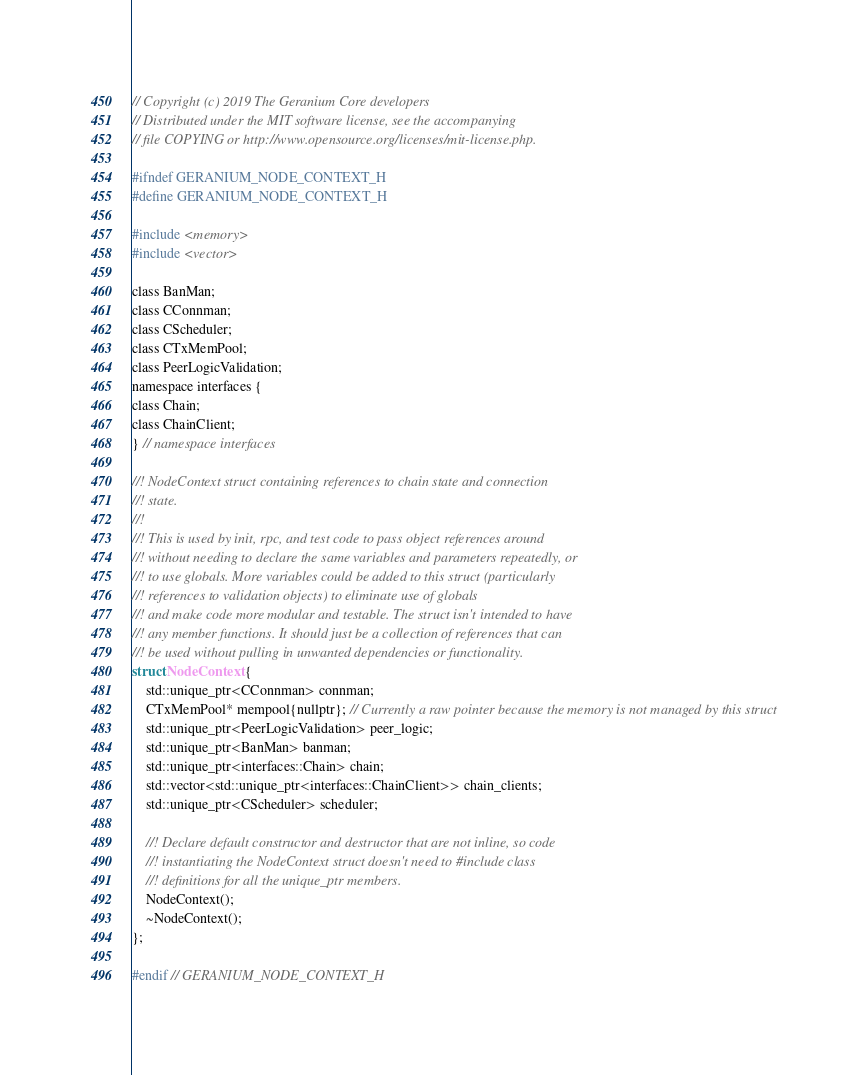<code> <loc_0><loc_0><loc_500><loc_500><_C_>// Copyright (c) 2019 The Geranium Core developers
// Distributed under the MIT software license, see the accompanying
// file COPYING or http://www.opensource.org/licenses/mit-license.php.

#ifndef GERANIUM_NODE_CONTEXT_H
#define GERANIUM_NODE_CONTEXT_H

#include <memory>
#include <vector>

class BanMan;
class CConnman;
class CScheduler;
class CTxMemPool;
class PeerLogicValidation;
namespace interfaces {
class Chain;
class ChainClient;
} // namespace interfaces

//! NodeContext struct containing references to chain state and connection
//! state.
//!
//! This is used by init, rpc, and test code to pass object references around
//! without needing to declare the same variables and parameters repeatedly, or
//! to use globals. More variables could be added to this struct (particularly
//! references to validation objects) to eliminate use of globals
//! and make code more modular and testable. The struct isn't intended to have
//! any member functions. It should just be a collection of references that can
//! be used without pulling in unwanted dependencies or functionality.
struct NodeContext {
    std::unique_ptr<CConnman> connman;
    CTxMemPool* mempool{nullptr}; // Currently a raw pointer because the memory is not managed by this struct
    std::unique_ptr<PeerLogicValidation> peer_logic;
    std::unique_ptr<BanMan> banman;
    std::unique_ptr<interfaces::Chain> chain;
    std::vector<std::unique_ptr<interfaces::ChainClient>> chain_clients;
    std::unique_ptr<CScheduler> scheduler;

    //! Declare default constructor and destructor that are not inline, so code
    //! instantiating the NodeContext struct doesn't need to #include class
    //! definitions for all the unique_ptr members.
    NodeContext();
    ~NodeContext();
};

#endif // GERANIUM_NODE_CONTEXT_H
</code> 